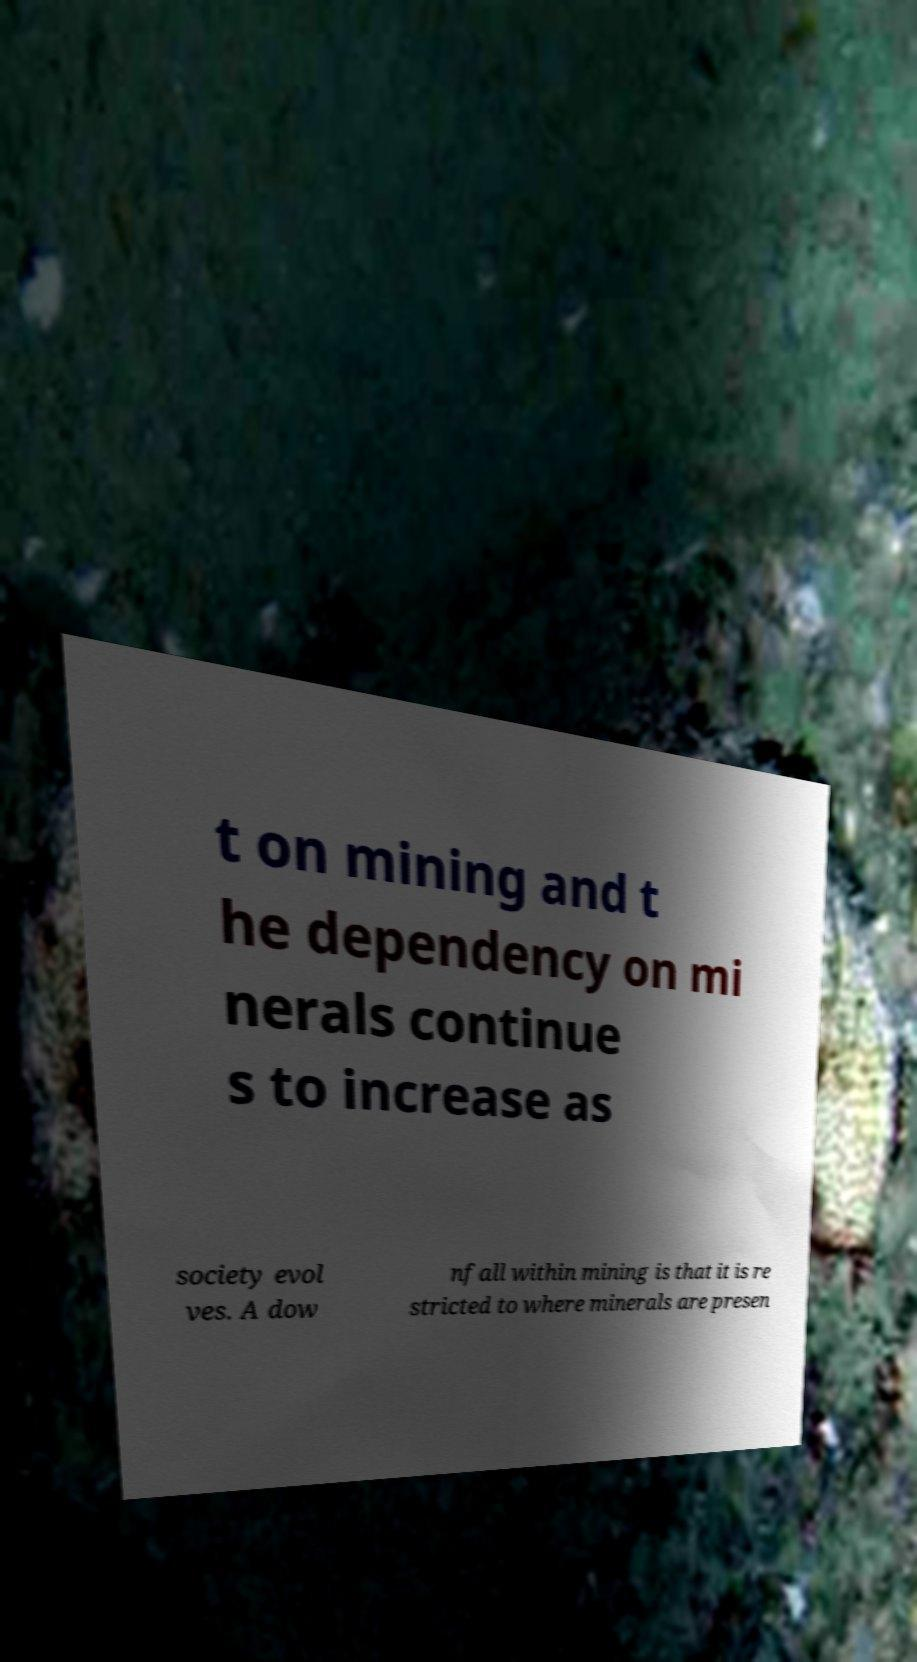Could you assist in decoding the text presented in this image and type it out clearly? t on mining and t he dependency on mi nerals continue s to increase as society evol ves. A dow nfall within mining is that it is re stricted to where minerals are presen 